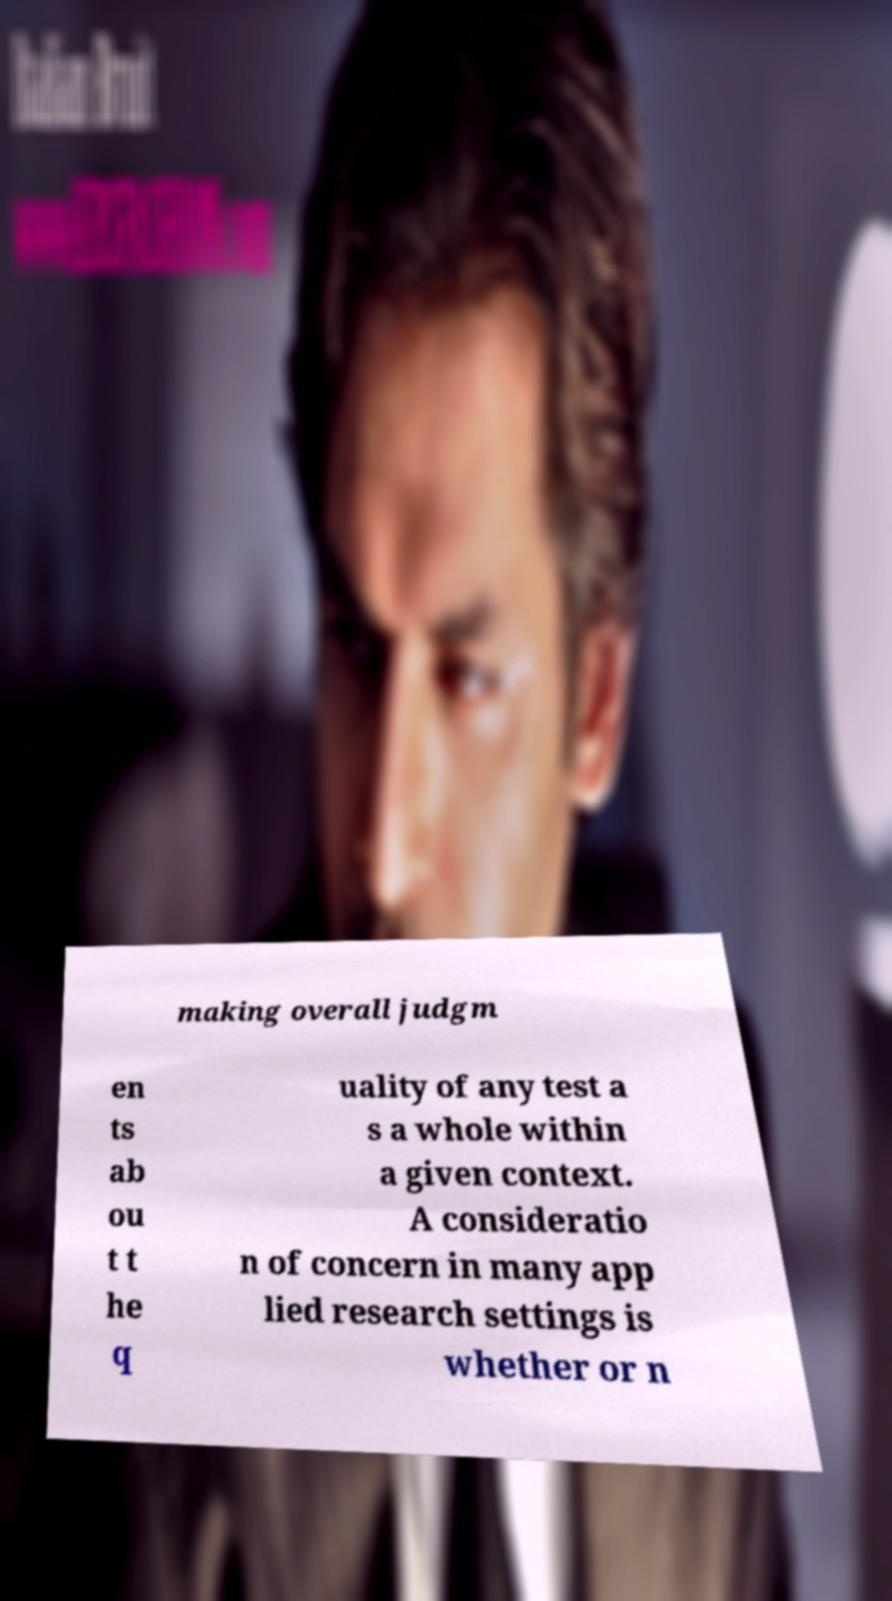Could you assist in decoding the text presented in this image and type it out clearly? making overall judgm en ts ab ou t t he q uality of any test a s a whole within a given context. A consideratio n of concern in many app lied research settings is whether or n 